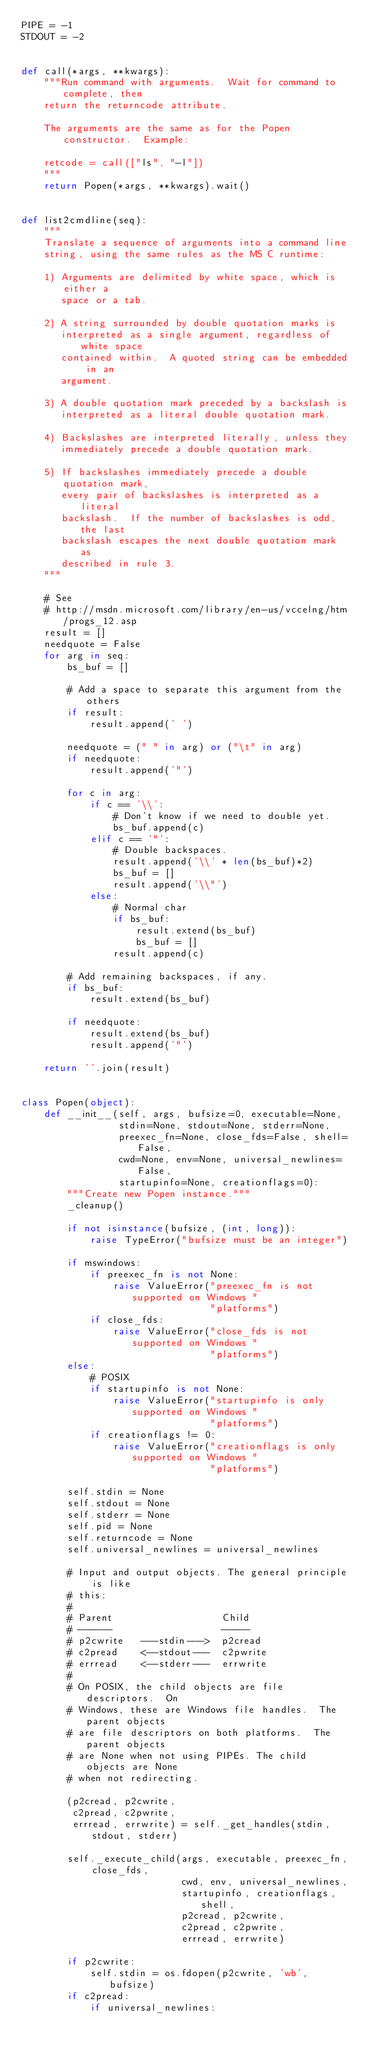Convert code to text. <code><loc_0><loc_0><loc_500><loc_500><_Python_>PIPE = -1
STDOUT = -2


def call(*args, **kwargs):
    """Run command with arguments.  Wait for command to complete, then
    return the returncode attribute.

    The arguments are the same as for the Popen constructor.  Example:

    retcode = call(["ls", "-l"])
    """
    return Popen(*args, **kwargs).wait()


def list2cmdline(seq):
    """
    Translate a sequence of arguments into a command line
    string, using the same rules as the MS C runtime:

    1) Arguments are delimited by white space, which is either a
       space or a tab.

    2) A string surrounded by double quotation marks is
       interpreted as a single argument, regardless of white space
       contained within.  A quoted string can be embedded in an
       argument.

    3) A double quotation mark preceded by a backslash is
       interpreted as a literal double quotation mark.

    4) Backslashes are interpreted literally, unless they
       immediately precede a double quotation mark.

    5) If backslashes immediately precede a double quotation mark,
       every pair of backslashes is interpreted as a literal
       backslash.  If the number of backslashes is odd, the last
       backslash escapes the next double quotation mark as
       described in rule 3.
    """

    # See
    # http://msdn.microsoft.com/library/en-us/vccelng/htm/progs_12.asp
    result = []
    needquote = False
    for arg in seq:
        bs_buf = []

        # Add a space to separate this argument from the others
        if result:
            result.append(' ')

        needquote = (" " in arg) or ("\t" in arg)
        if needquote:
            result.append('"')

        for c in arg:
            if c == '\\':
                # Don't know if we need to double yet.
                bs_buf.append(c)
            elif c == '"':
                # Double backspaces.
                result.append('\\' * len(bs_buf)*2)
                bs_buf = []
                result.append('\\"')
            else:
                # Normal char
                if bs_buf:
                    result.extend(bs_buf)
                    bs_buf = []
                result.append(c)

        # Add remaining backspaces, if any.
        if bs_buf:
            result.extend(bs_buf)

        if needquote:
            result.extend(bs_buf)
            result.append('"')

    return ''.join(result)


class Popen(object):
    def __init__(self, args, bufsize=0, executable=None,
                 stdin=None, stdout=None, stderr=None,
                 preexec_fn=None, close_fds=False, shell=False,
                 cwd=None, env=None, universal_newlines=False,
                 startupinfo=None, creationflags=0):
        """Create new Popen instance."""
        _cleanup()

        if not isinstance(bufsize, (int, long)):
            raise TypeError("bufsize must be an integer")

        if mswindows:
            if preexec_fn is not None:
                raise ValueError("preexec_fn is not supported on Windows "
                                 "platforms")
            if close_fds:
                raise ValueError("close_fds is not supported on Windows "
                                 "platforms")
        else:
            # POSIX
            if startupinfo is not None:
                raise ValueError("startupinfo is only supported on Windows "
                                 "platforms")
            if creationflags != 0:
                raise ValueError("creationflags is only supported on Windows "
                                 "platforms")

        self.stdin = None
        self.stdout = None
        self.stderr = None
        self.pid = None
        self.returncode = None
        self.universal_newlines = universal_newlines

        # Input and output objects. The general principle is like
        # this:
        #
        # Parent                   Child
        # ------                   -----
        # p2cwrite   ---stdin--->  p2cread
        # c2pread    <--stdout---  c2pwrite
        # errread    <--stderr---  errwrite
        #
        # On POSIX, the child objects are file descriptors.  On
        # Windows, these are Windows file handles.  The parent objects
        # are file descriptors on both platforms.  The parent objects
        # are None when not using PIPEs. The child objects are None
        # when not redirecting.

        (p2cread, p2cwrite,
         c2pread, c2pwrite,
         errread, errwrite) = self._get_handles(stdin, stdout, stderr)

        self._execute_child(args, executable, preexec_fn, close_fds,
                            cwd, env, universal_newlines,
                            startupinfo, creationflags, shell,
                            p2cread, p2cwrite,
                            c2pread, c2pwrite,
                            errread, errwrite)

        if p2cwrite:
            self.stdin = os.fdopen(p2cwrite, 'wb', bufsize)
        if c2pread:
            if universal_newlines:</code> 